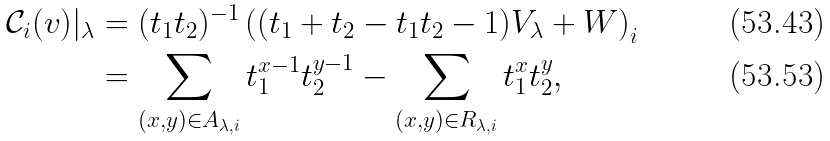<formula> <loc_0><loc_0><loc_500><loc_500>\mathcal { C } _ { i } ( { v } ) | _ { \lambda } & = ( t _ { 1 } t _ { 2 } ) ^ { - 1 } \left ( ( t _ { 1 } + t _ { 2 } - t _ { 1 } t _ { 2 } - 1 ) V _ { \lambda } + W \right ) _ { i } \\ & = \sum _ { ( x , y ) \in A _ { \lambda , i } } t _ { 1 } ^ { x - 1 } t _ { 2 } ^ { y - 1 } - \sum _ { ( x , y ) \in R _ { \lambda , i } } t _ { 1 } ^ { x } t _ { 2 } ^ { y } ,</formula> 